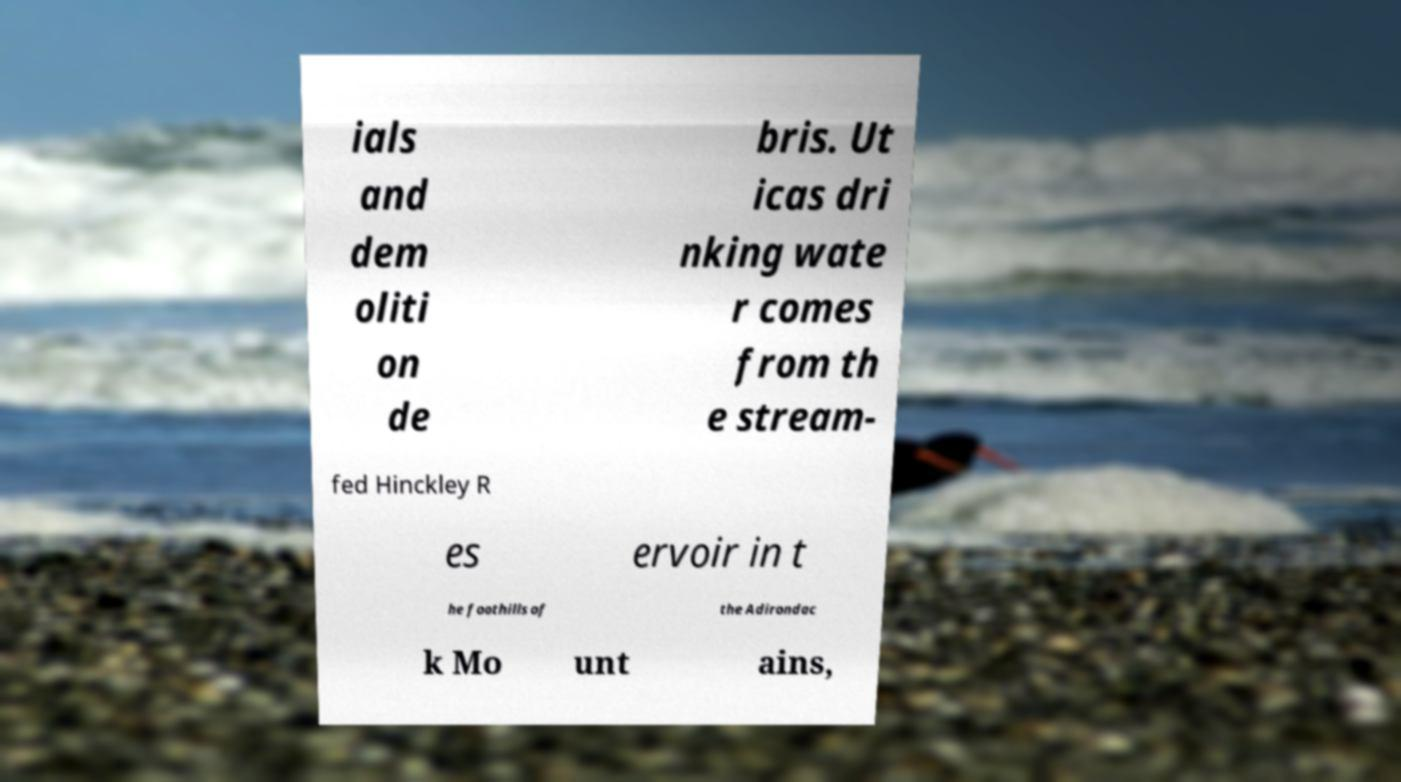Please read and relay the text visible in this image. What does it say? ials and dem oliti on de bris. Ut icas dri nking wate r comes from th e stream- fed Hinckley R es ervoir in t he foothills of the Adirondac k Mo unt ains, 